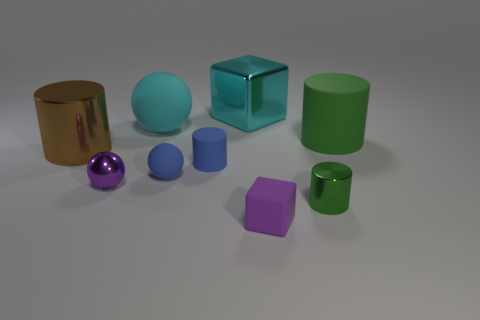Add 1 red matte balls. How many objects exist? 10 Subtract all balls. How many objects are left? 6 Subtract 0 green spheres. How many objects are left? 9 Subtract all tiny gray rubber balls. Subtract all small blue rubber objects. How many objects are left? 7 Add 2 tiny blue matte cylinders. How many tiny blue matte cylinders are left? 3 Add 2 large blue cylinders. How many large blue cylinders exist? 2 